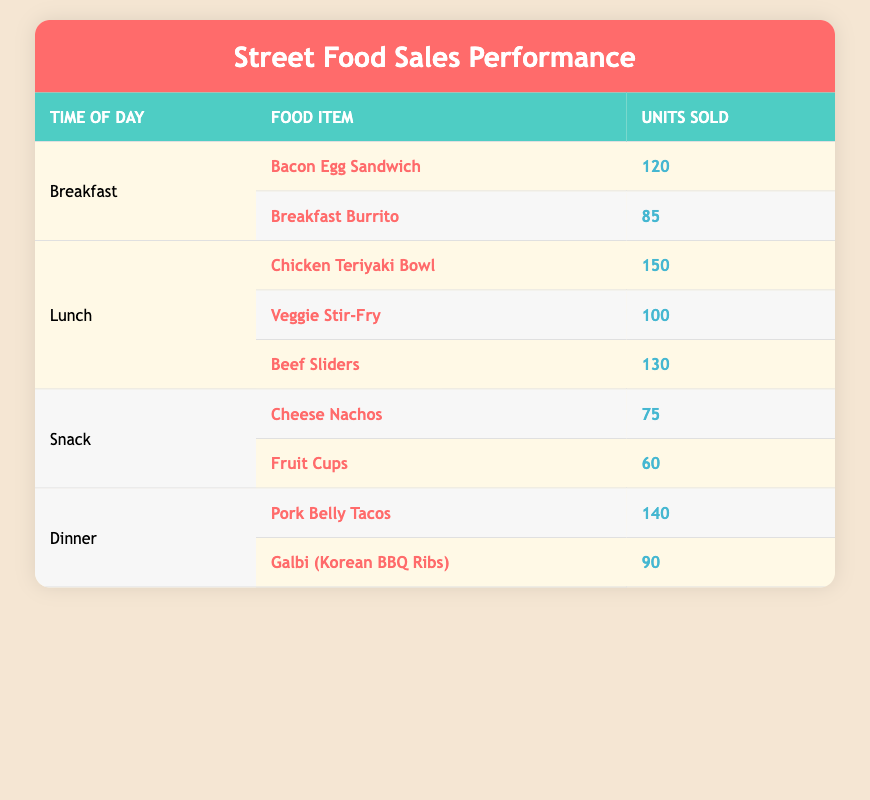What food item sold the most during lunch? The table shows three food items sold during lunch: Chicken Teriyaki Bowl (150 units), Veggie Stir-Fry (100 units), and Beef Sliders (130 units). The Chicken Teriyaki Bowl has the highest units sold, with 150.
Answer: Chicken Teriyaki Bowl How many units of snacks were sold in total? There are two snack items: Cheese Nachos sold 75 units and Fruit Cups sold 60 units. The total units sold for snacks is calculated as 75 + 60 = 135.
Answer: 135 Did the Breakfast Burrito sell more than the Cheese Nachos? The Breakfast Burrito sold 85 units while Cheese Nachos sold 75 units. Since 85 is greater than 75, the Breakfast Burrito sold more.
Answer: Yes What is the average number of units sold per food item during dinner? There are two dinner items: Pork Belly Tacos sold 140 units, and Galbi (Korean BBQ Ribs) sold 90 units. The average is calculated by summing the units (140 + 90 = 230) and dividing by the number of items (2). Thus, the average is 230 / 2 = 115.
Answer: 115 Which time of day had the least total sales? For Breakfast: 120 + 85 = 205; Lunch: 150 + 100 + 130 = 380; Snack: 75 + 60 = 135; Dinner: 140 + 90 = 230. Comparing total sales, Snack has the least total units sold at 135.
Answer: Snack 